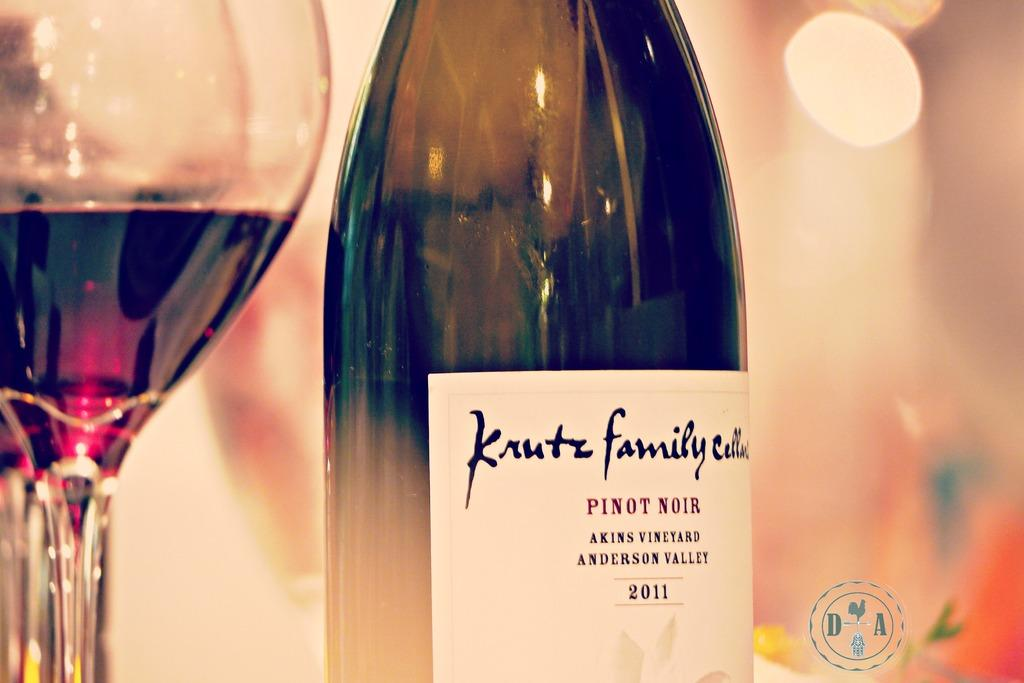What type of beverage container is present in the image? There is a wine bottle in the image. What is the wine bottle paired with in the image? There is a glass of drink in the image. Can you describe the background of the image? The background of the image is colorful. How many leaves can be seen on the glass in the image? There are no leaves present in the image; it features a wine bottle and a glass of drink. 